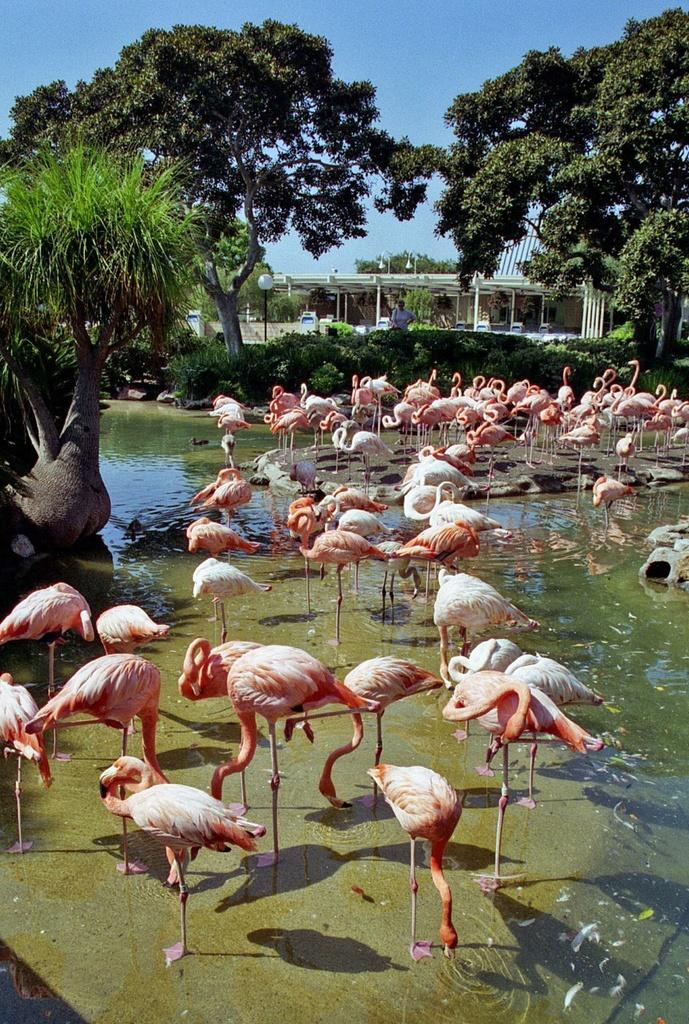What type of animals are in the water in the image? There are flamingo birds in the water in the image. What can be seen in the background of the image? There are trees, a house, and the sky visible in the background of the image. What structures are present in the image? There are light poles in the image. Is there a person in the image? Yes, there is a person standing in the image. What type of paste is being used by the flamingo birds in the image? There is no paste present in the image; the flamingo birds are in the water. 